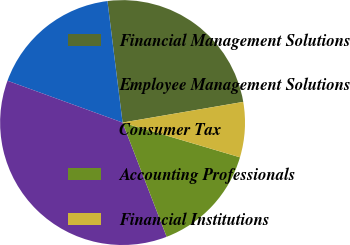<chart> <loc_0><loc_0><loc_500><loc_500><pie_chart><fcel>Financial Management Solutions<fcel>Employee Management Solutions<fcel>Consumer Tax<fcel>Accounting Professionals<fcel>Financial Institutions<nl><fcel>24.27%<fcel>17.48%<fcel>36.41%<fcel>14.56%<fcel>7.28%<nl></chart> 